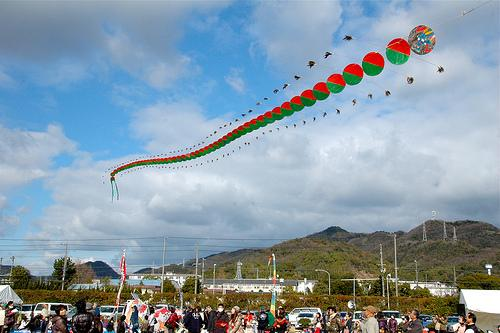Mention two significant features in the image. A large dragon kite is flying in the blue and cloudy sky, while a crowd of people enjoy flying their kites near power poles and parked cars. Describe the surroundings where the main event of the image is happening. It's a bright day with a mountain range in the background, powerlines, some parked cars and a small white building. Describe the weather and atmosphere displayed in the image. The weather is partly cloudy with blue and gray skies, and the atmosphere is cheerful and vibrant with people flying kites outdoors. Depict the most distinct features of this image. A large dragon kite soars above the kites, while the people fly kites beneath a cloudy sky, obscuring the mountains in the background. Write a one-sentence summary of the image. People enjoy flying various kites on a partly cloudy day near mountains, powerlines, and parked cars. Briefly describe the main activity happening in the image. A group of people is flying kites in a field near a mountain, with cars parked nearby and powerlines in the background. Mention three noticeable objects or aspects of the image. A large dragon kite in the sky, a crowd of people flying kites, and a white truck parked in the background. Provide a comprehensive description of the scene in the image. The image shows a group of people flying different kites in a field near a mountain, with powerlines and poles in the background, and some cars parked nearby. The sky is a mix of blue and gray with white clouds. What are the people in the image doing and what are the conditions of the sky? The people are flying kites and the sky is a mix of bright blue with gray and white clouds. Point out two different types of kites flying in the image. A large dragon kite and a few smaller red and green kites fly against the cloudy sky. 